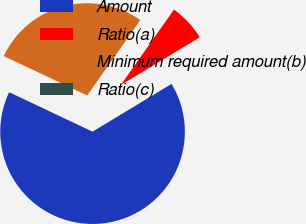Convert chart to OTSL. <chart><loc_0><loc_0><loc_500><loc_500><pie_chart><fcel>Amount<fcel>Ratio(a)<fcel>Minimum required amount(b)<fcel>Ratio(c)<nl><fcel>65.69%<fcel>6.57%<fcel>27.74%<fcel>0.0%<nl></chart> 